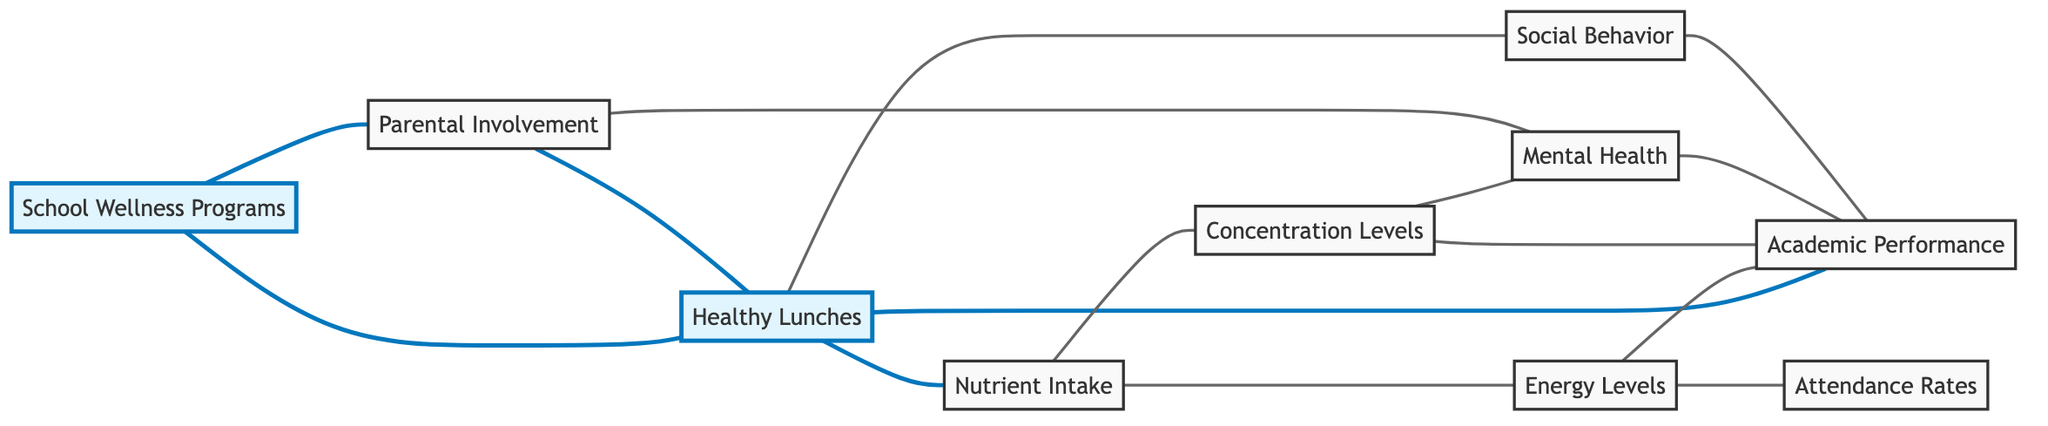What is the total number of nodes in the diagram? The diagram includes ten nodes representing different factors related to nutrition and academic performance. They are: Healthy Lunches, Academic Performance, Concentration Levels, Attendance Rates, Nutrient Intake, Energy Levels, Social Behavior, Mental Health, School Wellness Programs, and Parental Involvement.
Answer: ten Which factor is directly connected to healthy lunches? The factors that are directly connected to Healthy Lunches in the diagram are Academic Performance, Nutrient Intake, Social Behavior, and School Wellness Programs. Therefore, there are multiple connections, but one such factor is Academic Performance.
Answer: Academic Performance How many edges are there in total? To find the total number of edges connecting the nodes, we count each connection represented in the diagram. There are fourteen edges shown in the provided data.
Answer: fourteen Which two factors are connected by an edge in relation to concentration levels? The factors connected to Concentration Levels via edges are Nutrient Intake and Mental Health. Both are directly linked to Concentration Levels, indicating a relationship between diet and concentration.
Answer: Nutrient Intake and Mental Health What is the relationship between energy levels and attendance rates? Energy Levels has a direct edge connecting it to Attendance Rates, indicating that as energy levels increase, attendance rates may also improve, suggesting a possible positive influence on attendance.
Answer: connected Which factor has a direct influence on both academic performance and mental health? Mental Health is directly influenced by Concentration Levels, which also influences Academic Performance. Therefore, Concentration Levels acts as the connection between Academic Performance and Mental Health.
Answer: Concentration Levels How many different ways can parental involvement influence other factors? Parental Involvement influences two factors: Healthy Lunches and Mental Health. These relationships show that parental involvement can affect wellness and mental health positively.
Answer: two Is there any connection observed between social behavior and academic performance? Yes, there is a direct edge connecting Social Behavior to Academic Performance in the diagram, showing that improved social behavior can have a positive impact on academic success.
Answer: yes What is the connection between school wellness programs and healthy lunches? School Wellness Programs have a direct connection to Healthy Lunches in the diagram, indicating that wellness programs may advocate for or support the implementation of healthy lunch options in schools.
Answer: direct connection 